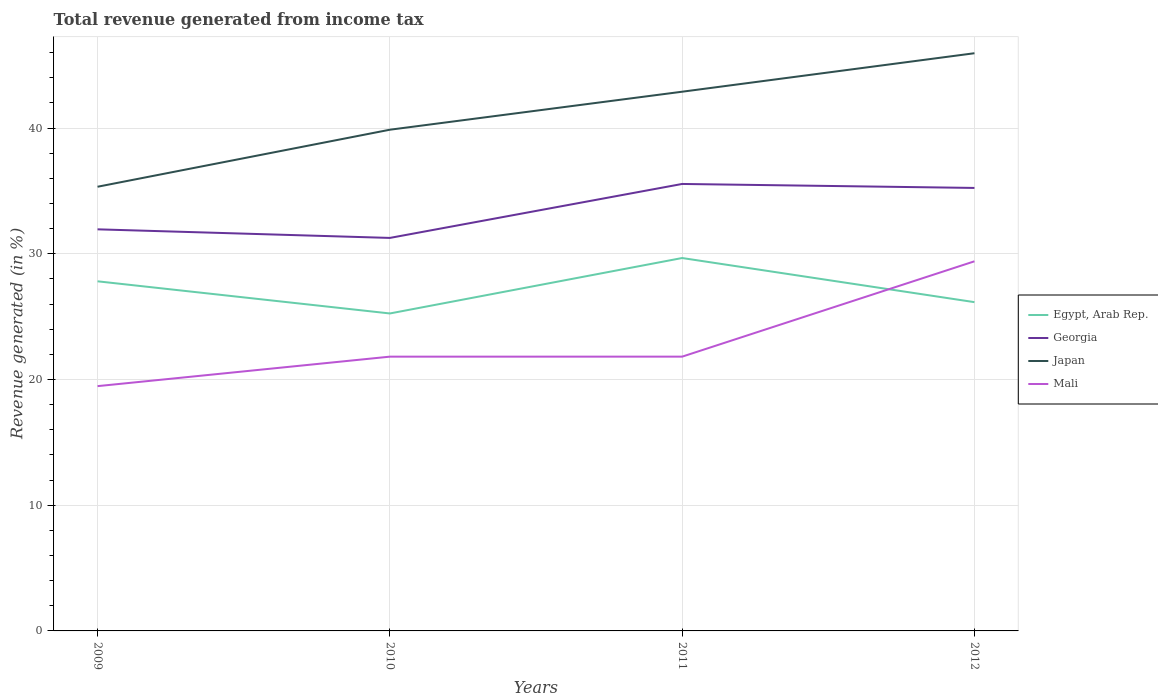How many different coloured lines are there?
Your answer should be compact. 4. Is the number of lines equal to the number of legend labels?
Your response must be concise. Yes. Across all years, what is the maximum total revenue generated in Egypt, Arab Rep.?
Give a very brief answer. 25.26. In which year was the total revenue generated in Egypt, Arab Rep. maximum?
Provide a short and direct response. 2010. What is the total total revenue generated in Mali in the graph?
Offer a very short reply. -9.93. What is the difference between the highest and the second highest total revenue generated in Japan?
Give a very brief answer. 10.62. What is the difference between the highest and the lowest total revenue generated in Mali?
Offer a very short reply. 1. Does the graph contain any zero values?
Your response must be concise. No. How are the legend labels stacked?
Make the answer very short. Vertical. What is the title of the graph?
Your answer should be very brief. Total revenue generated from income tax. Does "Bahrain" appear as one of the legend labels in the graph?
Your response must be concise. No. What is the label or title of the Y-axis?
Ensure brevity in your answer.  Revenue generated (in %). What is the Revenue generated (in %) in Egypt, Arab Rep. in 2009?
Your answer should be very brief. 27.81. What is the Revenue generated (in %) in Georgia in 2009?
Your answer should be very brief. 31.95. What is the Revenue generated (in %) in Japan in 2009?
Give a very brief answer. 35.34. What is the Revenue generated (in %) of Mali in 2009?
Offer a very short reply. 19.47. What is the Revenue generated (in %) of Egypt, Arab Rep. in 2010?
Give a very brief answer. 25.26. What is the Revenue generated (in %) in Georgia in 2010?
Provide a short and direct response. 31.26. What is the Revenue generated (in %) in Japan in 2010?
Keep it short and to the point. 39.87. What is the Revenue generated (in %) of Mali in 2010?
Provide a succinct answer. 21.82. What is the Revenue generated (in %) in Egypt, Arab Rep. in 2011?
Offer a very short reply. 29.67. What is the Revenue generated (in %) in Georgia in 2011?
Offer a terse response. 35.56. What is the Revenue generated (in %) of Japan in 2011?
Give a very brief answer. 42.9. What is the Revenue generated (in %) of Mali in 2011?
Offer a terse response. 21.82. What is the Revenue generated (in %) of Egypt, Arab Rep. in 2012?
Keep it short and to the point. 26.15. What is the Revenue generated (in %) of Georgia in 2012?
Keep it short and to the point. 35.24. What is the Revenue generated (in %) of Japan in 2012?
Offer a terse response. 45.96. What is the Revenue generated (in %) of Mali in 2012?
Offer a terse response. 29.4. Across all years, what is the maximum Revenue generated (in %) of Egypt, Arab Rep.?
Ensure brevity in your answer.  29.67. Across all years, what is the maximum Revenue generated (in %) in Georgia?
Give a very brief answer. 35.56. Across all years, what is the maximum Revenue generated (in %) in Japan?
Your response must be concise. 45.96. Across all years, what is the maximum Revenue generated (in %) of Mali?
Your answer should be very brief. 29.4. Across all years, what is the minimum Revenue generated (in %) of Egypt, Arab Rep.?
Your answer should be compact. 25.26. Across all years, what is the minimum Revenue generated (in %) of Georgia?
Your response must be concise. 31.26. Across all years, what is the minimum Revenue generated (in %) in Japan?
Provide a succinct answer. 35.34. Across all years, what is the minimum Revenue generated (in %) of Mali?
Offer a very short reply. 19.47. What is the total Revenue generated (in %) of Egypt, Arab Rep. in the graph?
Your answer should be very brief. 108.89. What is the total Revenue generated (in %) of Georgia in the graph?
Your answer should be compact. 134.01. What is the total Revenue generated (in %) in Japan in the graph?
Provide a short and direct response. 164.06. What is the total Revenue generated (in %) of Mali in the graph?
Provide a short and direct response. 92.52. What is the difference between the Revenue generated (in %) of Egypt, Arab Rep. in 2009 and that in 2010?
Ensure brevity in your answer.  2.56. What is the difference between the Revenue generated (in %) of Georgia in 2009 and that in 2010?
Your response must be concise. 0.68. What is the difference between the Revenue generated (in %) of Japan in 2009 and that in 2010?
Your answer should be very brief. -4.54. What is the difference between the Revenue generated (in %) of Mali in 2009 and that in 2010?
Ensure brevity in your answer.  -2.35. What is the difference between the Revenue generated (in %) in Egypt, Arab Rep. in 2009 and that in 2011?
Offer a very short reply. -1.85. What is the difference between the Revenue generated (in %) of Georgia in 2009 and that in 2011?
Ensure brevity in your answer.  -3.61. What is the difference between the Revenue generated (in %) of Japan in 2009 and that in 2011?
Your answer should be compact. -7.56. What is the difference between the Revenue generated (in %) of Mali in 2009 and that in 2011?
Ensure brevity in your answer.  -2.35. What is the difference between the Revenue generated (in %) of Egypt, Arab Rep. in 2009 and that in 2012?
Your response must be concise. 1.66. What is the difference between the Revenue generated (in %) of Georgia in 2009 and that in 2012?
Offer a very short reply. -3.29. What is the difference between the Revenue generated (in %) in Japan in 2009 and that in 2012?
Provide a short and direct response. -10.62. What is the difference between the Revenue generated (in %) in Mali in 2009 and that in 2012?
Offer a very short reply. -9.93. What is the difference between the Revenue generated (in %) in Egypt, Arab Rep. in 2010 and that in 2011?
Offer a terse response. -4.41. What is the difference between the Revenue generated (in %) of Georgia in 2010 and that in 2011?
Ensure brevity in your answer.  -4.29. What is the difference between the Revenue generated (in %) of Japan in 2010 and that in 2011?
Keep it short and to the point. -3.02. What is the difference between the Revenue generated (in %) of Mali in 2010 and that in 2011?
Provide a short and direct response. -0. What is the difference between the Revenue generated (in %) of Egypt, Arab Rep. in 2010 and that in 2012?
Offer a very short reply. -0.9. What is the difference between the Revenue generated (in %) of Georgia in 2010 and that in 2012?
Offer a very short reply. -3.98. What is the difference between the Revenue generated (in %) of Japan in 2010 and that in 2012?
Offer a very short reply. -6.09. What is the difference between the Revenue generated (in %) of Mali in 2010 and that in 2012?
Give a very brief answer. -7.59. What is the difference between the Revenue generated (in %) in Egypt, Arab Rep. in 2011 and that in 2012?
Provide a succinct answer. 3.51. What is the difference between the Revenue generated (in %) in Georgia in 2011 and that in 2012?
Make the answer very short. 0.32. What is the difference between the Revenue generated (in %) of Japan in 2011 and that in 2012?
Ensure brevity in your answer.  -3.06. What is the difference between the Revenue generated (in %) in Mali in 2011 and that in 2012?
Your answer should be very brief. -7.58. What is the difference between the Revenue generated (in %) in Egypt, Arab Rep. in 2009 and the Revenue generated (in %) in Georgia in 2010?
Offer a terse response. -3.45. What is the difference between the Revenue generated (in %) in Egypt, Arab Rep. in 2009 and the Revenue generated (in %) in Japan in 2010?
Offer a terse response. -12.06. What is the difference between the Revenue generated (in %) in Egypt, Arab Rep. in 2009 and the Revenue generated (in %) in Mali in 2010?
Offer a very short reply. 5.99. What is the difference between the Revenue generated (in %) in Georgia in 2009 and the Revenue generated (in %) in Japan in 2010?
Ensure brevity in your answer.  -7.92. What is the difference between the Revenue generated (in %) in Georgia in 2009 and the Revenue generated (in %) in Mali in 2010?
Offer a terse response. 10.13. What is the difference between the Revenue generated (in %) of Japan in 2009 and the Revenue generated (in %) of Mali in 2010?
Ensure brevity in your answer.  13.52. What is the difference between the Revenue generated (in %) of Egypt, Arab Rep. in 2009 and the Revenue generated (in %) of Georgia in 2011?
Provide a short and direct response. -7.74. What is the difference between the Revenue generated (in %) in Egypt, Arab Rep. in 2009 and the Revenue generated (in %) in Japan in 2011?
Make the answer very short. -15.08. What is the difference between the Revenue generated (in %) in Egypt, Arab Rep. in 2009 and the Revenue generated (in %) in Mali in 2011?
Offer a terse response. 5.99. What is the difference between the Revenue generated (in %) of Georgia in 2009 and the Revenue generated (in %) of Japan in 2011?
Make the answer very short. -10.95. What is the difference between the Revenue generated (in %) of Georgia in 2009 and the Revenue generated (in %) of Mali in 2011?
Provide a succinct answer. 10.13. What is the difference between the Revenue generated (in %) in Japan in 2009 and the Revenue generated (in %) in Mali in 2011?
Make the answer very short. 13.52. What is the difference between the Revenue generated (in %) of Egypt, Arab Rep. in 2009 and the Revenue generated (in %) of Georgia in 2012?
Provide a succinct answer. -7.43. What is the difference between the Revenue generated (in %) in Egypt, Arab Rep. in 2009 and the Revenue generated (in %) in Japan in 2012?
Your answer should be very brief. -18.14. What is the difference between the Revenue generated (in %) in Egypt, Arab Rep. in 2009 and the Revenue generated (in %) in Mali in 2012?
Provide a succinct answer. -1.59. What is the difference between the Revenue generated (in %) in Georgia in 2009 and the Revenue generated (in %) in Japan in 2012?
Offer a terse response. -14.01. What is the difference between the Revenue generated (in %) in Georgia in 2009 and the Revenue generated (in %) in Mali in 2012?
Provide a succinct answer. 2.54. What is the difference between the Revenue generated (in %) of Japan in 2009 and the Revenue generated (in %) of Mali in 2012?
Give a very brief answer. 5.93. What is the difference between the Revenue generated (in %) in Egypt, Arab Rep. in 2010 and the Revenue generated (in %) in Georgia in 2011?
Give a very brief answer. -10.3. What is the difference between the Revenue generated (in %) of Egypt, Arab Rep. in 2010 and the Revenue generated (in %) of Japan in 2011?
Your answer should be very brief. -17.64. What is the difference between the Revenue generated (in %) in Egypt, Arab Rep. in 2010 and the Revenue generated (in %) in Mali in 2011?
Keep it short and to the point. 3.44. What is the difference between the Revenue generated (in %) of Georgia in 2010 and the Revenue generated (in %) of Japan in 2011?
Keep it short and to the point. -11.63. What is the difference between the Revenue generated (in %) in Georgia in 2010 and the Revenue generated (in %) in Mali in 2011?
Make the answer very short. 9.44. What is the difference between the Revenue generated (in %) in Japan in 2010 and the Revenue generated (in %) in Mali in 2011?
Make the answer very short. 18.05. What is the difference between the Revenue generated (in %) of Egypt, Arab Rep. in 2010 and the Revenue generated (in %) of Georgia in 2012?
Ensure brevity in your answer.  -9.99. What is the difference between the Revenue generated (in %) in Egypt, Arab Rep. in 2010 and the Revenue generated (in %) in Japan in 2012?
Ensure brevity in your answer.  -20.7. What is the difference between the Revenue generated (in %) in Egypt, Arab Rep. in 2010 and the Revenue generated (in %) in Mali in 2012?
Give a very brief answer. -4.15. What is the difference between the Revenue generated (in %) in Georgia in 2010 and the Revenue generated (in %) in Japan in 2012?
Ensure brevity in your answer.  -14.69. What is the difference between the Revenue generated (in %) of Georgia in 2010 and the Revenue generated (in %) of Mali in 2012?
Make the answer very short. 1.86. What is the difference between the Revenue generated (in %) in Japan in 2010 and the Revenue generated (in %) in Mali in 2012?
Your response must be concise. 10.47. What is the difference between the Revenue generated (in %) of Egypt, Arab Rep. in 2011 and the Revenue generated (in %) of Georgia in 2012?
Provide a short and direct response. -5.58. What is the difference between the Revenue generated (in %) of Egypt, Arab Rep. in 2011 and the Revenue generated (in %) of Japan in 2012?
Your answer should be compact. -16.29. What is the difference between the Revenue generated (in %) in Egypt, Arab Rep. in 2011 and the Revenue generated (in %) in Mali in 2012?
Your answer should be very brief. 0.26. What is the difference between the Revenue generated (in %) of Georgia in 2011 and the Revenue generated (in %) of Japan in 2012?
Your response must be concise. -10.4. What is the difference between the Revenue generated (in %) of Georgia in 2011 and the Revenue generated (in %) of Mali in 2012?
Your answer should be compact. 6.15. What is the difference between the Revenue generated (in %) in Japan in 2011 and the Revenue generated (in %) in Mali in 2012?
Your answer should be very brief. 13.49. What is the average Revenue generated (in %) of Egypt, Arab Rep. per year?
Ensure brevity in your answer.  27.22. What is the average Revenue generated (in %) of Georgia per year?
Provide a succinct answer. 33.5. What is the average Revenue generated (in %) in Japan per year?
Your answer should be very brief. 41.02. What is the average Revenue generated (in %) of Mali per year?
Your answer should be very brief. 23.13. In the year 2009, what is the difference between the Revenue generated (in %) in Egypt, Arab Rep. and Revenue generated (in %) in Georgia?
Ensure brevity in your answer.  -4.13. In the year 2009, what is the difference between the Revenue generated (in %) in Egypt, Arab Rep. and Revenue generated (in %) in Japan?
Keep it short and to the point. -7.52. In the year 2009, what is the difference between the Revenue generated (in %) in Egypt, Arab Rep. and Revenue generated (in %) in Mali?
Give a very brief answer. 8.34. In the year 2009, what is the difference between the Revenue generated (in %) of Georgia and Revenue generated (in %) of Japan?
Your answer should be very brief. -3.39. In the year 2009, what is the difference between the Revenue generated (in %) in Georgia and Revenue generated (in %) in Mali?
Your answer should be very brief. 12.47. In the year 2009, what is the difference between the Revenue generated (in %) in Japan and Revenue generated (in %) in Mali?
Keep it short and to the point. 15.86. In the year 2010, what is the difference between the Revenue generated (in %) of Egypt, Arab Rep. and Revenue generated (in %) of Georgia?
Give a very brief answer. -6.01. In the year 2010, what is the difference between the Revenue generated (in %) in Egypt, Arab Rep. and Revenue generated (in %) in Japan?
Offer a very short reply. -14.62. In the year 2010, what is the difference between the Revenue generated (in %) in Egypt, Arab Rep. and Revenue generated (in %) in Mali?
Ensure brevity in your answer.  3.44. In the year 2010, what is the difference between the Revenue generated (in %) in Georgia and Revenue generated (in %) in Japan?
Ensure brevity in your answer.  -8.61. In the year 2010, what is the difference between the Revenue generated (in %) in Georgia and Revenue generated (in %) in Mali?
Make the answer very short. 9.45. In the year 2010, what is the difference between the Revenue generated (in %) in Japan and Revenue generated (in %) in Mali?
Your response must be concise. 18.05. In the year 2011, what is the difference between the Revenue generated (in %) in Egypt, Arab Rep. and Revenue generated (in %) in Georgia?
Offer a very short reply. -5.89. In the year 2011, what is the difference between the Revenue generated (in %) in Egypt, Arab Rep. and Revenue generated (in %) in Japan?
Offer a terse response. -13.23. In the year 2011, what is the difference between the Revenue generated (in %) in Egypt, Arab Rep. and Revenue generated (in %) in Mali?
Offer a very short reply. 7.85. In the year 2011, what is the difference between the Revenue generated (in %) of Georgia and Revenue generated (in %) of Japan?
Ensure brevity in your answer.  -7.34. In the year 2011, what is the difference between the Revenue generated (in %) of Georgia and Revenue generated (in %) of Mali?
Provide a short and direct response. 13.74. In the year 2011, what is the difference between the Revenue generated (in %) in Japan and Revenue generated (in %) in Mali?
Offer a very short reply. 21.08. In the year 2012, what is the difference between the Revenue generated (in %) of Egypt, Arab Rep. and Revenue generated (in %) of Georgia?
Your response must be concise. -9.09. In the year 2012, what is the difference between the Revenue generated (in %) of Egypt, Arab Rep. and Revenue generated (in %) of Japan?
Provide a short and direct response. -19.8. In the year 2012, what is the difference between the Revenue generated (in %) in Egypt, Arab Rep. and Revenue generated (in %) in Mali?
Your answer should be compact. -3.25. In the year 2012, what is the difference between the Revenue generated (in %) in Georgia and Revenue generated (in %) in Japan?
Your answer should be compact. -10.72. In the year 2012, what is the difference between the Revenue generated (in %) of Georgia and Revenue generated (in %) of Mali?
Give a very brief answer. 5.84. In the year 2012, what is the difference between the Revenue generated (in %) in Japan and Revenue generated (in %) in Mali?
Your answer should be very brief. 16.55. What is the ratio of the Revenue generated (in %) of Egypt, Arab Rep. in 2009 to that in 2010?
Make the answer very short. 1.1. What is the ratio of the Revenue generated (in %) in Georgia in 2009 to that in 2010?
Your answer should be compact. 1.02. What is the ratio of the Revenue generated (in %) of Japan in 2009 to that in 2010?
Offer a very short reply. 0.89. What is the ratio of the Revenue generated (in %) in Mali in 2009 to that in 2010?
Offer a terse response. 0.89. What is the ratio of the Revenue generated (in %) of Egypt, Arab Rep. in 2009 to that in 2011?
Ensure brevity in your answer.  0.94. What is the ratio of the Revenue generated (in %) in Georgia in 2009 to that in 2011?
Offer a very short reply. 0.9. What is the ratio of the Revenue generated (in %) in Japan in 2009 to that in 2011?
Provide a short and direct response. 0.82. What is the ratio of the Revenue generated (in %) of Mali in 2009 to that in 2011?
Ensure brevity in your answer.  0.89. What is the ratio of the Revenue generated (in %) in Egypt, Arab Rep. in 2009 to that in 2012?
Provide a succinct answer. 1.06. What is the ratio of the Revenue generated (in %) of Georgia in 2009 to that in 2012?
Offer a very short reply. 0.91. What is the ratio of the Revenue generated (in %) of Japan in 2009 to that in 2012?
Offer a very short reply. 0.77. What is the ratio of the Revenue generated (in %) of Mali in 2009 to that in 2012?
Give a very brief answer. 0.66. What is the ratio of the Revenue generated (in %) in Egypt, Arab Rep. in 2010 to that in 2011?
Provide a short and direct response. 0.85. What is the ratio of the Revenue generated (in %) in Georgia in 2010 to that in 2011?
Provide a short and direct response. 0.88. What is the ratio of the Revenue generated (in %) in Japan in 2010 to that in 2011?
Give a very brief answer. 0.93. What is the ratio of the Revenue generated (in %) of Mali in 2010 to that in 2011?
Your answer should be very brief. 1. What is the ratio of the Revenue generated (in %) in Egypt, Arab Rep. in 2010 to that in 2012?
Make the answer very short. 0.97. What is the ratio of the Revenue generated (in %) in Georgia in 2010 to that in 2012?
Your response must be concise. 0.89. What is the ratio of the Revenue generated (in %) of Japan in 2010 to that in 2012?
Offer a terse response. 0.87. What is the ratio of the Revenue generated (in %) of Mali in 2010 to that in 2012?
Provide a succinct answer. 0.74. What is the ratio of the Revenue generated (in %) of Egypt, Arab Rep. in 2011 to that in 2012?
Your answer should be compact. 1.13. What is the ratio of the Revenue generated (in %) of Georgia in 2011 to that in 2012?
Offer a terse response. 1.01. What is the ratio of the Revenue generated (in %) of Japan in 2011 to that in 2012?
Make the answer very short. 0.93. What is the ratio of the Revenue generated (in %) of Mali in 2011 to that in 2012?
Keep it short and to the point. 0.74. What is the difference between the highest and the second highest Revenue generated (in %) in Egypt, Arab Rep.?
Provide a short and direct response. 1.85. What is the difference between the highest and the second highest Revenue generated (in %) in Georgia?
Make the answer very short. 0.32. What is the difference between the highest and the second highest Revenue generated (in %) in Japan?
Give a very brief answer. 3.06. What is the difference between the highest and the second highest Revenue generated (in %) in Mali?
Your answer should be very brief. 7.58. What is the difference between the highest and the lowest Revenue generated (in %) in Egypt, Arab Rep.?
Provide a short and direct response. 4.41. What is the difference between the highest and the lowest Revenue generated (in %) of Georgia?
Provide a short and direct response. 4.29. What is the difference between the highest and the lowest Revenue generated (in %) in Japan?
Your answer should be very brief. 10.62. What is the difference between the highest and the lowest Revenue generated (in %) of Mali?
Make the answer very short. 9.93. 